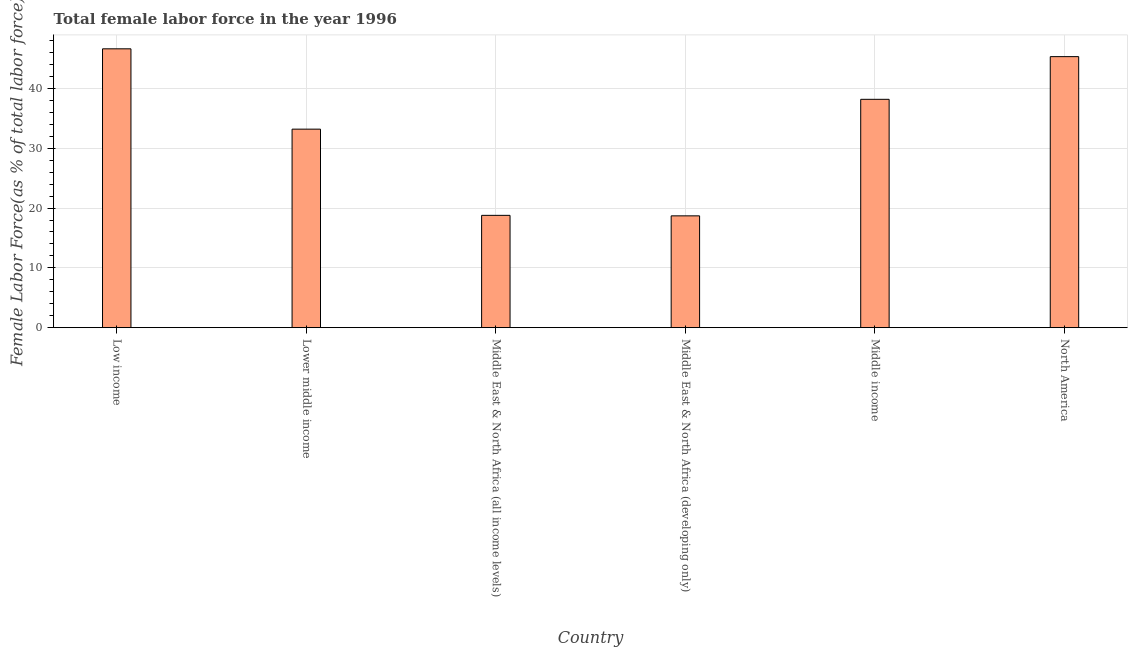What is the title of the graph?
Offer a very short reply. Total female labor force in the year 1996. What is the label or title of the X-axis?
Your answer should be very brief. Country. What is the label or title of the Y-axis?
Make the answer very short. Female Labor Force(as % of total labor force). What is the total female labor force in North America?
Your answer should be very brief. 45.31. Across all countries, what is the maximum total female labor force?
Keep it short and to the point. 46.62. Across all countries, what is the minimum total female labor force?
Ensure brevity in your answer.  18.69. In which country was the total female labor force maximum?
Give a very brief answer. Low income. In which country was the total female labor force minimum?
Make the answer very short. Middle East & North Africa (developing only). What is the sum of the total female labor force?
Give a very brief answer. 200.77. What is the difference between the total female labor force in Middle East & North Africa (developing only) and North America?
Provide a succinct answer. -26.62. What is the average total female labor force per country?
Provide a short and direct response. 33.46. What is the median total female labor force?
Give a very brief answer. 35.68. In how many countries, is the total female labor force greater than 30 %?
Give a very brief answer. 4. What is the ratio of the total female labor force in Lower middle income to that in North America?
Offer a very short reply. 0.73. Is the total female labor force in Low income less than that in North America?
Ensure brevity in your answer.  No. Is the difference between the total female labor force in Low income and Middle East & North Africa (all income levels) greater than the difference between any two countries?
Your answer should be very brief. No. What is the difference between the highest and the second highest total female labor force?
Offer a very short reply. 1.31. What is the difference between the highest and the lowest total female labor force?
Your answer should be compact. 27.93. In how many countries, is the total female labor force greater than the average total female labor force taken over all countries?
Your response must be concise. 3. Are all the bars in the graph horizontal?
Give a very brief answer. No. Are the values on the major ticks of Y-axis written in scientific E-notation?
Provide a short and direct response. No. What is the Female Labor Force(as % of total labor force) of Low income?
Make the answer very short. 46.62. What is the Female Labor Force(as % of total labor force) in Lower middle income?
Your answer should be compact. 33.19. What is the Female Labor Force(as % of total labor force) in Middle East & North Africa (all income levels)?
Ensure brevity in your answer.  18.78. What is the Female Labor Force(as % of total labor force) in Middle East & North Africa (developing only)?
Your response must be concise. 18.69. What is the Female Labor Force(as % of total labor force) in Middle income?
Ensure brevity in your answer.  38.18. What is the Female Labor Force(as % of total labor force) of North America?
Provide a short and direct response. 45.31. What is the difference between the Female Labor Force(as % of total labor force) in Low income and Lower middle income?
Provide a succinct answer. 13.43. What is the difference between the Female Labor Force(as % of total labor force) in Low income and Middle East & North Africa (all income levels)?
Your answer should be compact. 27.84. What is the difference between the Female Labor Force(as % of total labor force) in Low income and Middle East & North Africa (developing only)?
Your answer should be compact. 27.93. What is the difference between the Female Labor Force(as % of total labor force) in Low income and Middle income?
Your answer should be very brief. 8.44. What is the difference between the Female Labor Force(as % of total labor force) in Low income and North America?
Provide a short and direct response. 1.31. What is the difference between the Female Labor Force(as % of total labor force) in Lower middle income and Middle East & North Africa (all income levels)?
Offer a very short reply. 14.41. What is the difference between the Female Labor Force(as % of total labor force) in Lower middle income and Middle East & North Africa (developing only)?
Keep it short and to the point. 14.49. What is the difference between the Female Labor Force(as % of total labor force) in Lower middle income and Middle income?
Ensure brevity in your answer.  -4.99. What is the difference between the Female Labor Force(as % of total labor force) in Lower middle income and North America?
Your response must be concise. -12.13. What is the difference between the Female Labor Force(as % of total labor force) in Middle East & North Africa (all income levels) and Middle East & North Africa (developing only)?
Your response must be concise. 0.08. What is the difference between the Female Labor Force(as % of total labor force) in Middle East & North Africa (all income levels) and Middle income?
Offer a very short reply. -19.4. What is the difference between the Female Labor Force(as % of total labor force) in Middle East & North Africa (all income levels) and North America?
Ensure brevity in your answer.  -26.54. What is the difference between the Female Labor Force(as % of total labor force) in Middle East & North Africa (developing only) and Middle income?
Keep it short and to the point. -19.48. What is the difference between the Female Labor Force(as % of total labor force) in Middle East & North Africa (developing only) and North America?
Offer a terse response. -26.62. What is the difference between the Female Labor Force(as % of total labor force) in Middle income and North America?
Provide a succinct answer. -7.14. What is the ratio of the Female Labor Force(as % of total labor force) in Low income to that in Lower middle income?
Provide a succinct answer. 1.41. What is the ratio of the Female Labor Force(as % of total labor force) in Low income to that in Middle East & North Africa (all income levels)?
Provide a short and direct response. 2.48. What is the ratio of the Female Labor Force(as % of total labor force) in Low income to that in Middle East & North Africa (developing only)?
Provide a succinct answer. 2.49. What is the ratio of the Female Labor Force(as % of total labor force) in Low income to that in Middle income?
Give a very brief answer. 1.22. What is the ratio of the Female Labor Force(as % of total labor force) in Lower middle income to that in Middle East & North Africa (all income levels)?
Your response must be concise. 1.77. What is the ratio of the Female Labor Force(as % of total labor force) in Lower middle income to that in Middle East & North Africa (developing only)?
Keep it short and to the point. 1.77. What is the ratio of the Female Labor Force(as % of total labor force) in Lower middle income to that in Middle income?
Your answer should be compact. 0.87. What is the ratio of the Female Labor Force(as % of total labor force) in Lower middle income to that in North America?
Your answer should be compact. 0.73. What is the ratio of the Female Labor Force(as % of total labor force) in Middle East & North Africa (all income levels) to that in Middle income?
Your answer should be compact. 0.49. What is the ratio of the Female Labor Force(as % of total labor force) in Middle East & North Africa (all income levels) to that in North America?
Offer a very short reply. 0.41. What is the ratio of the Female Labor Force(as % of total labor force) in Middle East & North Africa (developing only) to that in Middle income?
Keep it short and to the point. 0.49. What is the ratio of the Female Labor Force(as % of total labor force) in Middle East & North Africa (developing only) to that in North America?
Provide a succinct answer. 0.41. What is the ratio of the Female Labor Force(as % of total labor force) in Middle income to that in North America?
Your answer should be very brief. 0.84. 